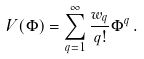<formula> <loc_0><loc_0><loc_500><loc_500>V ( \Phi ) = \sum _ { q = 1 } ^ { \infty } \frac { w _ { q } } { q ! } \Phi ^ { q } \, .</formula> 